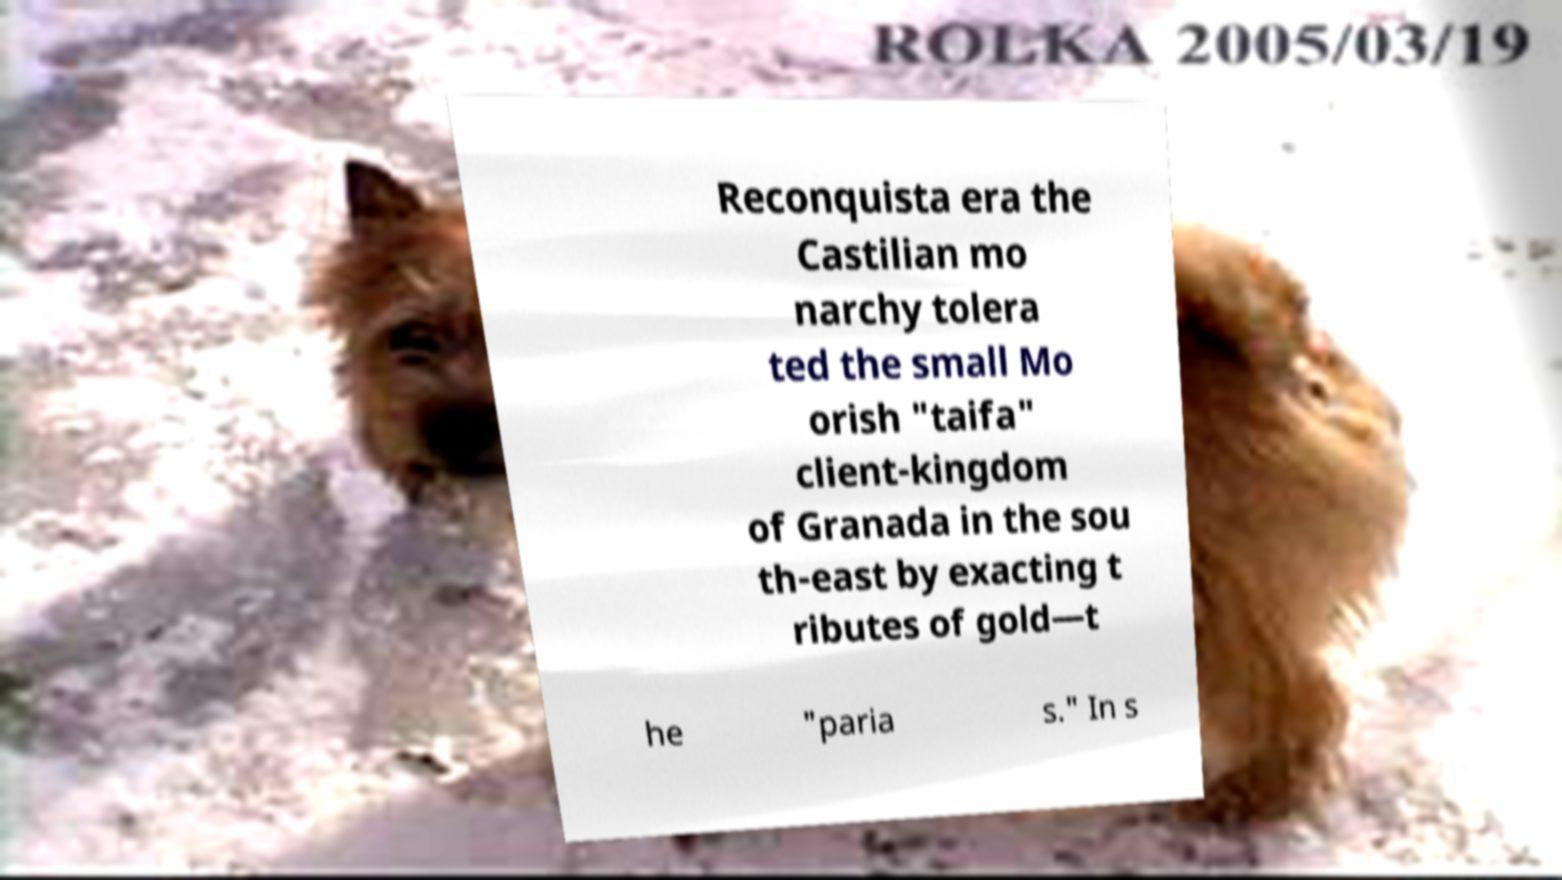Please read and relay the text visible in this image. What does it say? Reconquista era the Castilian mo narchy tolera ted the small Mo orish "taifa" client-kingdom of Granada in the sou th-east by exacting t ributes of gold—t he "paria s." In s 